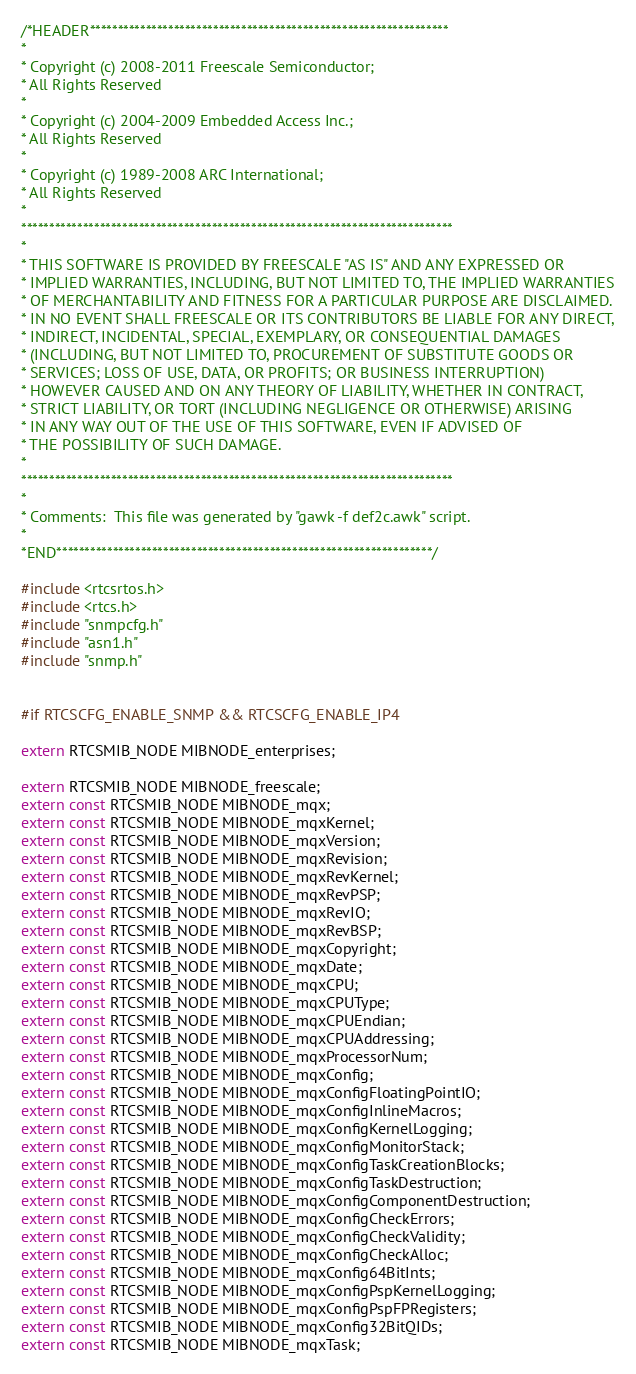Convert code to text. <code><loc_0><loc_0><loc_500><loc_500><_C_>/*HEADER****************************************************************
*
* Copyright (c) 2008-2011 Freescale Semiconductor;
* All Rights Reserved
*
* Copyright (c) 2004-2009 Embedded Access Inc.;
* All Rights Reserved
*
* Copyright (c) 1989-2008 ARC International;
* All Rights Reserved
*
***************************************************************************** 
*
* THIS SOFTWARE IS PROVIDED BY FREESCALE "AS IS" AND ANY EXPRESSED OR
* IMPLIED WARRANTIES, INCLUDING, BUT NOT LIMITED TO, THE IMPLIED WARRANTIES
* OF MERCHANTABILITY AND FITNESS FOR A PARTICULAR PURPOSE ARE DISCLAIMED.
* IN NO EVENT SHALL FREESCALE OR ITS CONTRIBUTORS BE LIABLE FOR ANY DIRECT,
* INDIRECT, INCIDENTAL, SPECIAL, EXEMPLARY, OR CONSEQUENTIAL DAMAGES
* (INCLUDING, BUT NOT LIMITED TO, PROCUREMENT OF SUBSTITUTE GOODS OR
* SERVICES; LOSS OF USE, DATA, OR PROFITS; OR BUSINESS INTERRUPTION)
* HOWEVER CAUSED AND ON ANY THEORY OF LIABILITY, WHETHER IN CONTRACT,
* STRICT LIABILITY, OR TORT (INCLUDING NEGLIGENCE OR OTHERWISE) ARISING
* IN ANY WAY OUT OF THE USE OF THIS SOFTWARE, EVEN IF ADVISED OF
* THE POSSIBILITY OF SUCH DAMAGE.
*
***************************************************************************** 
*
* Comments:  This file was generated by "gawk -f def2c.awk" script.
*
*END*******************************************************************/

#include <rtcsrtos.h>
#include <rtcs.h>
#include "snmpcfg.h"
#include "asn1.h"
#include "snmp.h"


#if RTCSCFG_ENABLE_SNMP && RTCSCFG_ENABLE_IP4

extern RTCSMIB_NODE MIBNODE_enterprises;

extern RTCSMIB_NODE MIBNODE_freescale;
extern const RTCSMIB_NODE MIBNODE_mqx;
extern const RTCSMIB_NODE MIBNODE_mqxKernel;
extern const RTCSMIB_NODE MIBNODE_mqxVersion;
extern const RTCSMIB_NODE MIBNODE_mqxRevision;
extern const RTCSMIB_NODE MIBNODE_mqxRevKernel;
extern const RTCSMIB_NODE MIBNODE_mqxRevPSP;
extern const RTCSMIB_NODE MIBNODE_mqxRevIO;
extern const RTCSMIB_NODE MIBNODE_mqxRevBSP;
extern const RTCSMIB_NODE MIBNODE_mqxCopyright;
extern const RTCSMIB_NODE MIBNODE_mqxDate;
extern const RTCSMIB_NODE MIBNODE_mqxCPU;
extern const RTCSMIB_NODE MIBNODE_mqxCPUType;
extern const RTCSMIB_NODE MIBNODE_mqxCPUEndian;
extern const RTCSMIB_NODE MIBNODE_mqxCPUAddressing;
extern const RTCSMIB_NODE MIBNODE_mqxProcessorNum;
extern const RTCSMIB_NODE MIBNODE_mqxConfig;
extern const RTCSMIB_NODE MIBNODE_mqxConfigFloatingPointIO;
extern const RTCSMIB_NODE MIBNODE_mqxConfigInlineMacros;
extern const RTCSMIB_NODE MIBNODE_mqxConfigKernelLogging;
extern const RTCSMIB_NODE MIBNODE_mqxConfigMonitorStack;
extern const RTCSMIB_NODE MIBNODE_mqxConfigTaskCreationBlocks;
extern const RTCSMIB_NODE MIBNODE_mqxConfigTaskDestruction;
extern const RTCSMIB_NODE MIBNODE_mqxConfigComponentDestruction;
extern const RTCSMIB_NODE MIBNODE_mqxConfigCheckErrors;
extern const RTCSMIB_NODE MIBNODE_mqxConfigCheckValidity;
extern const RTCSMIB_NODE MIBNODE_mqxConfigCheckAlloc;
extern const RTCSMIB_NODE MIBNODE_mqxConfig64BitInts;
extern const RTCSMIB_NODE MIBNODE_mqxConfigPspKernelLogging;
extern const RTCSMIB_NODE MIBNODE_mqxConfigPspFPRegisters;
extern const RTCSMIB_NODE MIBNODE_mqxConfig32BitQIDs;
extern const RTCSMIB_NODE MIBNODE_mqxTask;</code> 